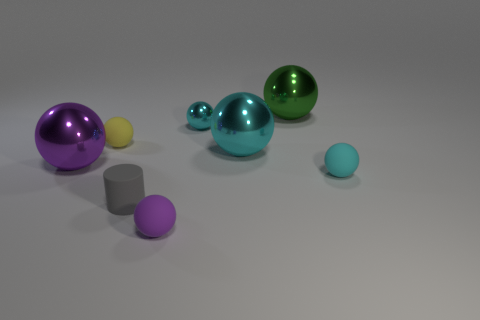How do the sizes of the spheres compare to each other? The spheres vary in size, with one large green sphere and a cyan sphere slightly smaller in comparison. There's a smaller purple sphere and yet a smaller sphere with a light pastel color. The cyan sphere is the largest among them, dominating in size. 